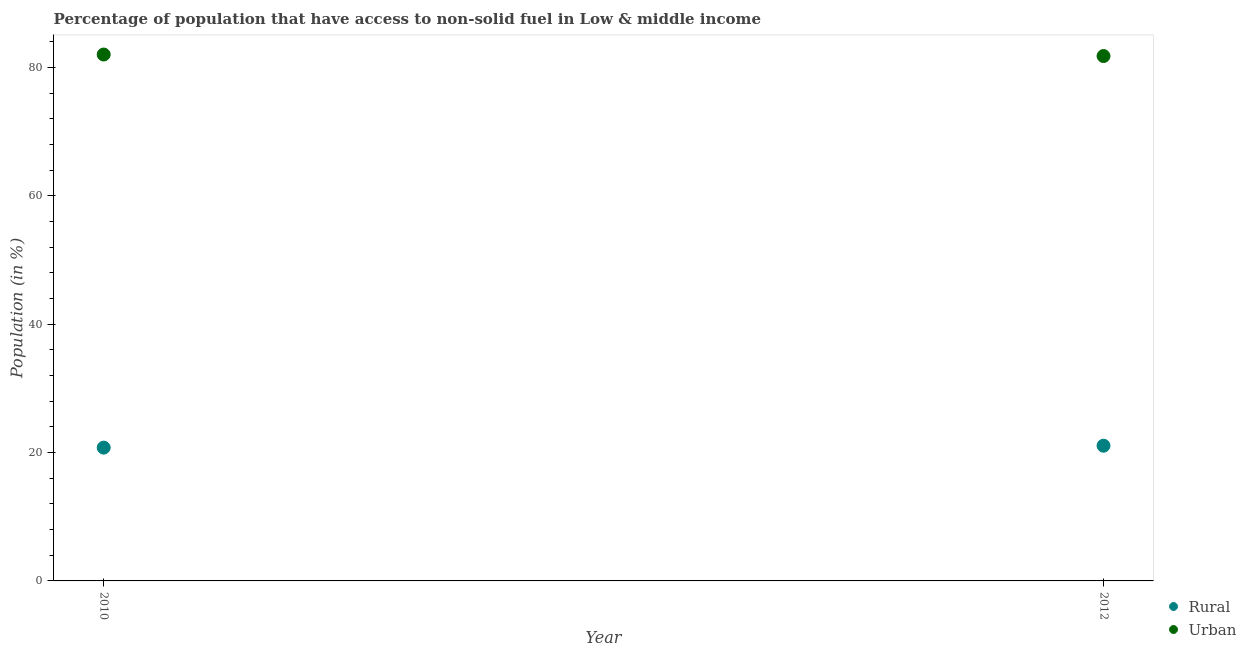How many different coloured dotlines are there?
Give a very brief answer. 2. What is the urban population in 2010?
Ensure brevity in your answer.  82.01. Across all years, what is the maximum urban population?
Offer a terse response. 82.01. Across all years, what is the minimum rural population?
Ensure brevity in your answer.  20.76. In which year was the urban population minimum?
Your answer should be very brief. 2012. What is the total urban population in the graph?
Your response must be concise. 163.78. What is the difference between the urban population in 2010 and that in 2012?
Your answer should be very brief. 0.24. What is the difference between the rural population in 2010 and the urban population in 2012?
Offer a terse response. -61.01. What is the average rural population per year?
Offer a very short reply. 20.91. In the year 2010, what is the difference between the urban population and rural population?
Offer a very short reply. 61.24. What is the ratio of the urban population in 2010 to that in 2012?
Your answer should be compact. 1. Is the urban population in 2010 less than that in 2012?
Ensure brevity in your answer.  No. Does the rural population monotonically increase over the years?
Your answer should be very brief. Yes. Is the urban population strictly greater than the rural population over the years?
Make the answer very short. Yes. Is the rural population strictly less than the urban population over the years?
Your answer should be very brief. Yes. Are the values on the major ticks of Y-axis written in scientific E-notation?
Make the answer very short. No. Does the graph contain any zero values?
Make the answer very short. No. Where does the legend appear in the graph?
Ensure brevity in your answer.  Bottom right. How many legend labels are there?
Make the answer very short. 2. How are the legend labels stacked?
Your answer should be very brief. Vertical. What is the title of the graph?
Keep it short and to the point. Percentage of population that have access to non-solid fuel in Low & middle income. What is the Population (in %) of Rural in 2010?
Your answer should be very brief. 20.76. What is the Population (in %) of Urban in 2010?
Your response must be concise. 82.01. What is the Population (in %) in Rural in 2012?
Keep it short and to the point. 21.06. What is the Population (in %) in Urban in 2012?
Your answer should be very brief. 81.77. Across all years, what is the maximum Population (in %) in Rural?
Make the answer very short. 21.06. Across all years, what is the maximum Population (in %) in Urban?
Give a very brief answer. 82.01. Across all years, what is the minimum Population (in %) of Rural?
Your answer should be very brief. 20.76. Across all years, what is the minimum Population (in %) of Urban?
Your answer should be compact. 81.77. What is the total Population (in %) of Rural in the graph?
Ensure brevity in your answer.  41.83. What is the total Population (in %) in Urban in the graph?
Provide a short and direct response. 163.78. What is the difference between the Population (in %) of Rural in 2010 and that in 2012?
Give a very brief answer. -0.3. What is the difference between the Population (in %) of Urban in 2010 and that in 2012?
Keep it short and to the point. 0.24. What is the difference between the Population (in %) of Rural in 2010 and the Population (in %) of Urban in 2012?
Your answer should be compact. -61.01. What is the average Population (in %) in Rural per year?
Offer a terse response. 20.91. What is the average Population (in %) in Urban per year?
Offer a very short reply. 81.89. In the year 2010, what is the difference between the Population (in %) in Rural and Population (in %) in Urban?
Keep it short and to the point. -61.24. In the year 2012, what is the difference between the Population (in %) in Rural and Population (in %) in Urban?
Provide a short and direct response. -60.71. What is the ratio of the Population (in %) of Rural in 2010 to that in 2012?
Provide a short and direct response. 0.99. What is the ratio of the Population (in %) in Urban in 2010 to that in 2012?
Make the answer very short. 1. What is the difference between the highest and the second highest Population (in %) of Rural?
Ensure brevity in your answer.  0.3. What is the difference between the highest and the second highest Population (in %) of Urban?
Offer a terse response. 0.24. What is the difference between the highest and the lowest Population (in %) of Rural?
Ensure brevity in your answer.  0.3. What is the difference between the highest and the lowest Population (in %) of Urban?
Your answer should be very brief. 0.24. 